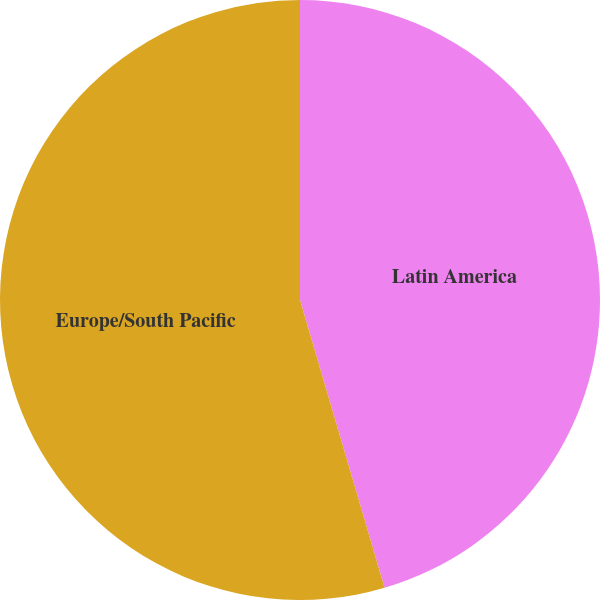Convert chart. <chart><loc_0><loc_0><loc_500><loc_500><pie_chart><fcel>Latin America<fcel>Europe/South Pacific<nl><fcel>45.45%<fcel>54.55%<nl></chart> 